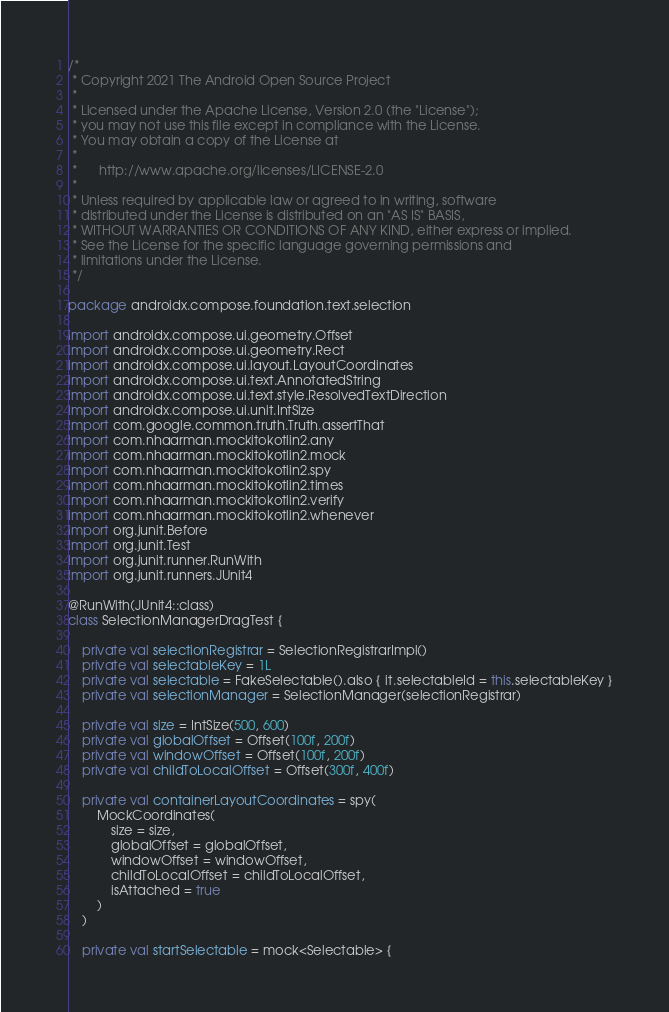<code> <loc_0><loc_0><loc_500><loc_500><_Kotlin_>/*
 * Copyright 2021 The Android Open Source Project
 *
 * Licensed under the Apache License, Version 2.0 (the "License");
 * you may not use this file except in compliance with the License.
 * You may obtain a copy of the License at
 *
 *      http://www.apache.org/licenses/LICENSE-2.0
 *
 * Unless required by applicable law or agreed to in writing, software
 * distributed under the License is distributed on an "AS IS" BASIS,
 * WITHOUT WARRANTIES OR CONDITIONS OF ANY KIND, either express or implied.
 * See the License for the specific language governing permissions and
 * limitations under the License.
 */

package androidx.compose.foundation.text.selection

import androidx.compose.ui.geometry.Offset
import androidx.compose.ui.geometry.Rect
import androidx.compose.ui.layout.LayoutCoordinates
import androidx.compose.ui.text.AnnotatedString
import androidx.compose.ui.text.style.ResolvedTextDirection
import androidx.compose.ui.unit.IntSize
import com.google.common.truth.Truth.assertThat
import com.nhaarman.mockitokotlin2.any
import com.nhaarman.mockitokotlin2.mock
import com.nhaarman.mockitokotlin2.spy
import com.nhaarman.mockitokotlin2.times
import com.nhaarman.mockitokotlin2.verify
import com.nhaarman.mockitokotlin2.whenever
import org.junit.Before
import org.junit.Test
import org.junit.runner.RunWith
import org.junit.runners.JUnit4

@RunWith(JUnit4::class)
class SelectionManagerDragTest {

    private val selectionRegistrar = SelectionRegistrarImpl()
    private val selectableKey = 1L
    private val selectable = FakeSelectable().also { it.selectableId = this.selectableKey }
    private val selectionManager = SelectionManager(selectionRegistrar)

    private val size = IntSize(500, 600)
    private val globalOffset = Offset(100f, 200f)
    private val windowOffset = Offset(100f, 200f)
    private val childToLocalOffset = Offset(300f, 400f)

    private val containerLayoutCoordinates = spy(
        MockCoordinates(
            size = size,
            globalOffset = globalOffset,
            windowOffset = windowOffset,
            childToLocalOffset = childToLocalOffset,
            isAttached = true
        )
    )

    private val startSelectable = mock<Selectable> {</code> 